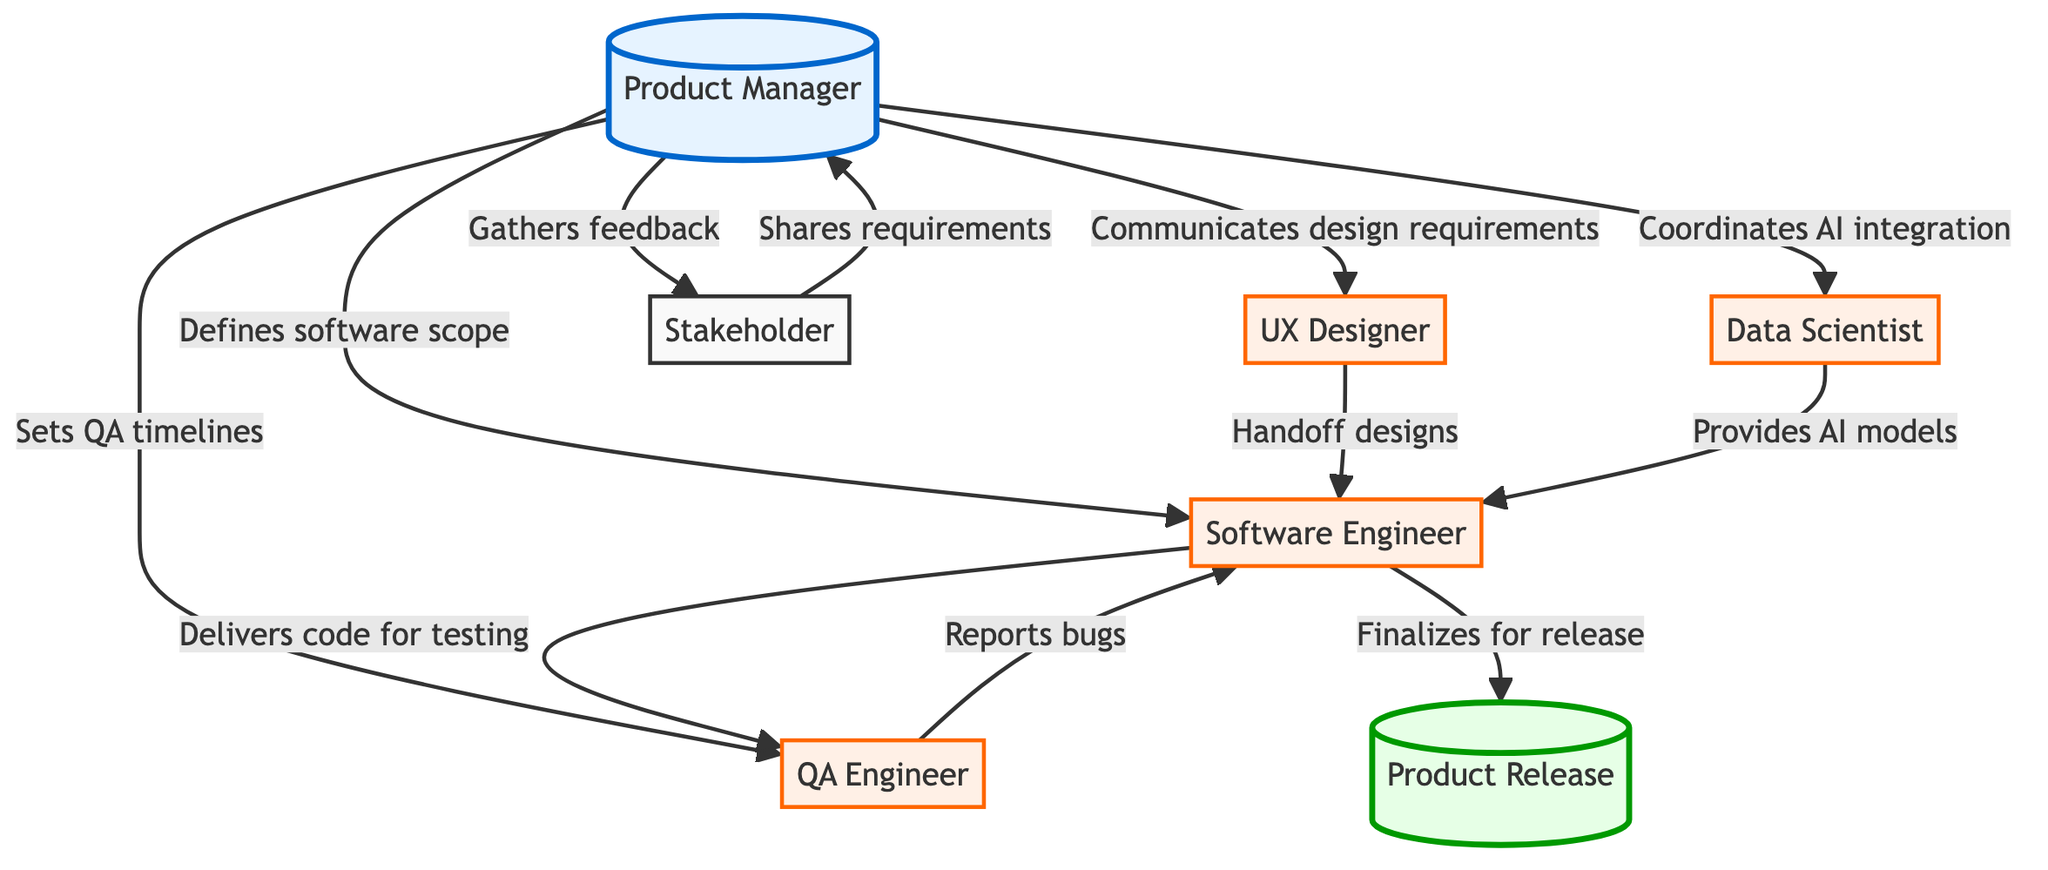What is the total number of nodes in the diagram? Counting the nodes listed in the data, we see seven distinct roles labeled: Product Manager, UX Designer, Software Engineer, Data Scientist, QA Engineer, Stakeholder, and Product Release.
Answer: 7 Who does the Product Manager communicate design requirements to? According to the diagram, the arrow labeled "Communicates design requirements" leads from the Product Manager to the UX Designer, indicating that the Product Manager communicates with the UX Designer.
Answer: UX Designer How many edges are there in the diagram? By examining the connections or edges specified in the data, there are a total of ten connections between different nodes that illustrate their relationships.
Answer: 10 Which role hands off designs to the Software Engineer? The edge labeled "Handoff designs" connects the UX Designer to the Software Engineer, indicating that the UX Designer is responsible for handing off designs.
Answer: UX Designer What role does the Data Scientist provide AI models and algorithms to? The connection is shown as "Provides AI models and algorithms" directed from the Data Scientist to the Software Engineer, which indicates that the Data Scientist provides valuable inputs to the Software Engineer.
Answer: Software Engineer What is the last action the Software Engineer performs in the process? The edge labeled "Finalizes for release" indicates that the last action undertaken by the Software Engineer is completing their work before the product is released.
Answer: Finalizes for release Which node receives requirements shared by the Stakeholder? The Stakeholder shares their requirements with the Product Manager as indicated by the arrow labeled "Shares requirements" that leads to the Product Manager.
Answer: Product Manager Identify the role responsible for testing software for bugs and quality assurance. The edge labeled "Reports bugs" indicates that the QA Engineer is a node responsible for testing software to ensure quality and to identify bugs throughout the development lifecycle.
Answer: QA Engineer 